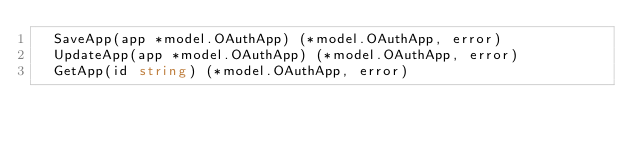<code> <loc_0><loc_0><loc_500><loc_500><_Go_>	SaveApp(app *model.OAuthApp) (*model.OAuthApp, error)
	UpdateApp(app *model.OAuthApp) (*model.OAuthApp, error)
	GetApp(id string) (*model.OAuthApp, error)</code> 